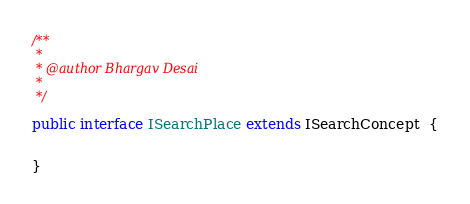<code> <loc_0><loc_0><loc_500><loc_500><_Java_>/**
 * 
 * @author Bhargav Desai
 *
 */

public interface ISearchPlace extends ISearchConcept  {

	
}
</code> 